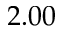Convert formula to latex. <formula><loc_0><loc_0><loc_500><loc_500>2 . 0 0</formula> 